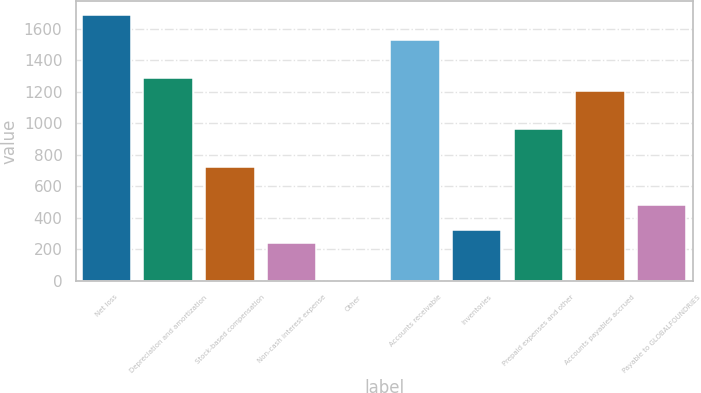Convert chart. <chart><loc_0><loc_0><loc_500><loc_500><bar_chart><fcel>Net loss<fcel>Depreciation and amortization<fcel>Stock-based compensation<fcel>Non-cash interest expense<fcel>Other<fcel>Accounts receivable<fcel>Inventories<fcel>Prepaid expenses and other<fcel>Accounts payables accrued<fcel>Payable to GLOBALFOUNDRIES<nl><fcel>1687.2<fcel>1286.2<fcel>724.8<fcel>243.6<fcel>3<fcel>1526.8<fcel>323.8<fcel>965.4<fcel>1206<fcel>484.2<nl></chart> 